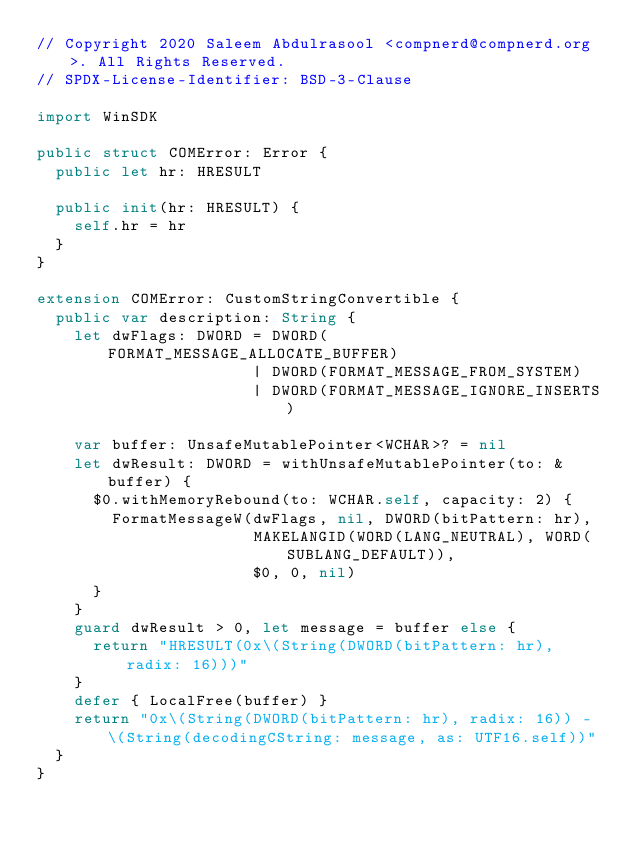<code> <loc_0><loc_0><loc_500><loc_500><_Swift_>// Copyright 2020 Saleem Abdulrasool <compnerd@compnerd.org>. All Rights Reserved.
// SPDX-License-Identifier: BSD-3-Clause

import WinSDK

public struct COMError: Error {
  public let hr: HRESULT

  public init(hr: HRESULT) {
    self.hr = hr
  }
}

extension COMError: CustomStringConvertible {
  public var description: String {
    let dwFlags: DWORD = DWORD(FORMAT_MESSAGE_ALLOCATE_BUFFER)
                       | DWORD(FORMAT_MESSAGE_FROM_SYSTEM)
                       | DWORD(FORMAT_MESSAGE_IGNORE_INSERTS)

    var buffer: UnsafeMutablePointer<WCHAR>? = nil
    let dwResult: DWORD = withUnsafeMutablePointer(to: &buffer) {
      $0.withMemoryRebound(to: WCHAR.self, capacity: 2) {
        FormatMessageW(dwFlags, nil, DWORD(bitPattern: hr),
                       MAKELANGID(WORD(LANG_NEUTRAL), WORD(SUBLANG_DEFAULT)),
                       $0, 0, nil)
      }
    }
    guard dwResult > 0, let message = buffer else {
      return "HRESULT(0x\(String(DWORD(bitPattern: hr), radix: 16)))"
    }
    defer { LocalFree(buffer) }
    return "0x\(String(DWORD(bitPattern: hr), radix: 16)) - \(String(decodingCString: message, as: UTF16.self))"
  }
}
</code> 